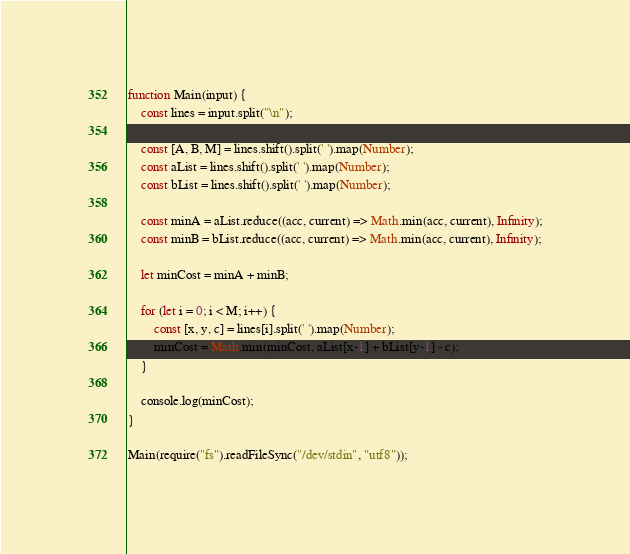Convert code to text. <code><loc_0><loc_0><loc_500><loc_500><_TypeScript_>function Main(input) {
    const lines = input.split("\n");

    const [A, B, M] = lines.shift().split(' ').map(Number);
    const aList = lines.shift().split(' ').map(Number);
    const bList = lines.shift().split(' ').map(Number);

    const minA = aList.reduce((acc, current) => Math.min(acc, current), Infinity);
    const minB = bList.reduce((acc, current) => Math.min(acc, current), Infinity);

    let minCost = minA + minB;

    for (let i = 0; i < M; i++) {
        const [x, y, c] = lines[i].split(' ').map(Number);
        minCost = Math.min(minCost, aList[x-1] + bList[y-1] - c);
    }

    console.log(minCost);
}

Main(require("fs").readFileSync("/dev/stdin", "utf8"));
</code> 